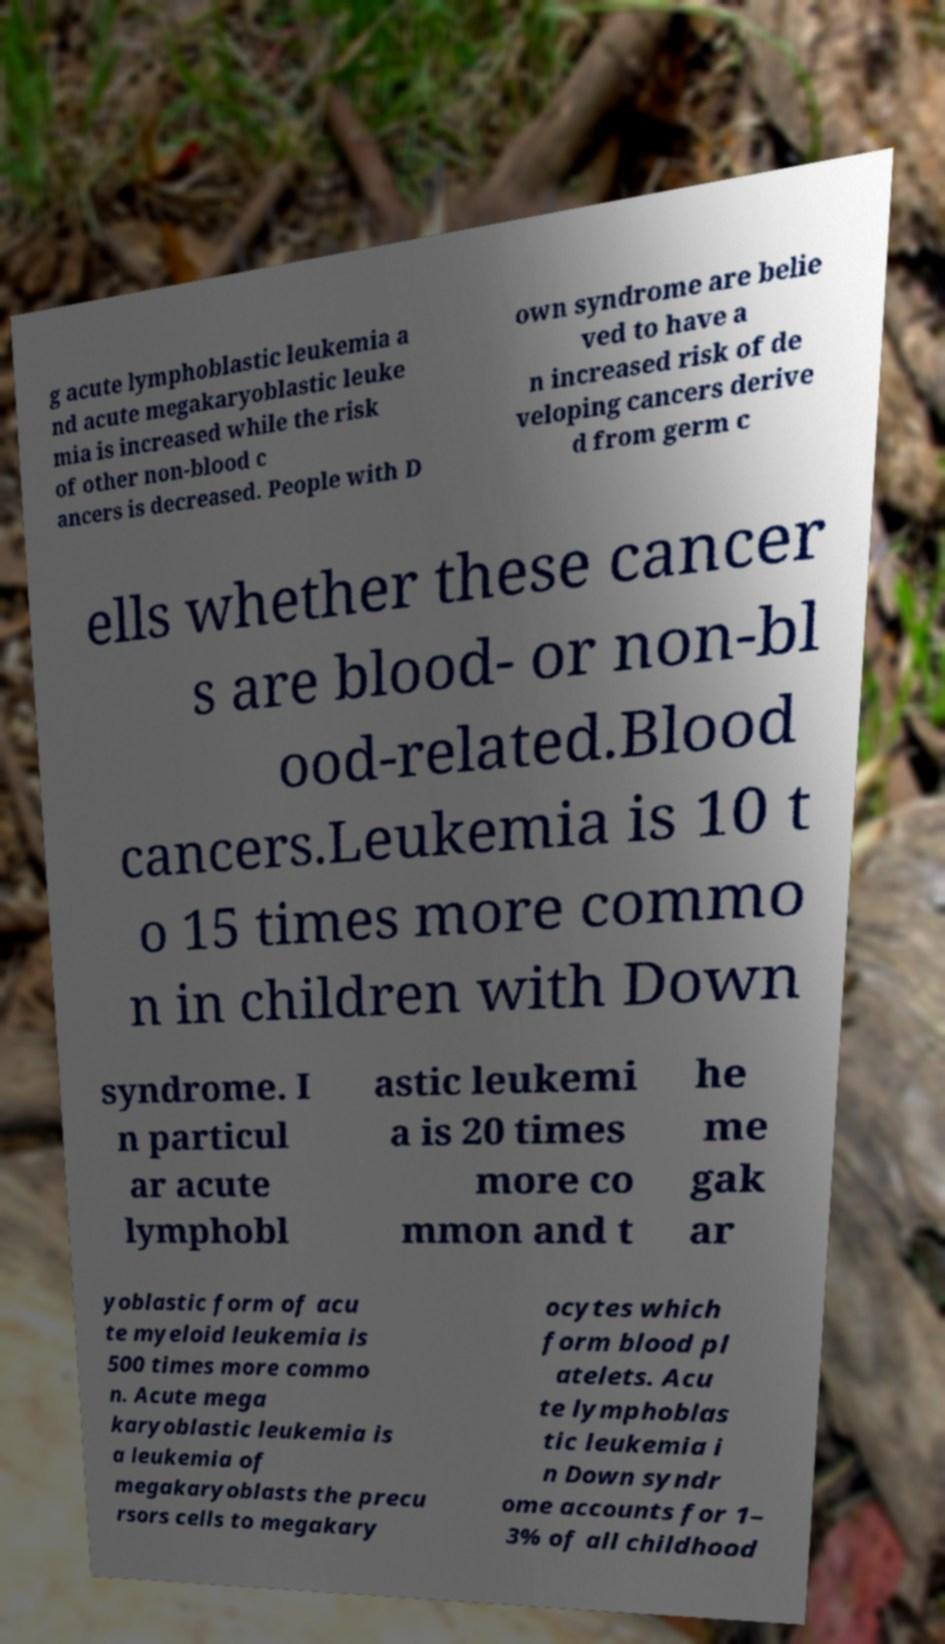Please read and relay the text visible in this image. What does it say? g acute lymphoblastic leukemia a nd acute megakaryoblastic leuke mia is increased while the risk of other non-blood c ancers is decreased. People with D own syndrome are belie ved to have a n increased risk of de veloping cancers derive d from germ c ells whether these cancer s are blood- or non-bl ood-related.Blood cancers.Leukemia is 10 t o 15 times more commo n in children with Down syndrome. I n particul ar acute lymphobl astic leukemi a is 20 times more co mmon and t he me gak ar yoblastic form of acu te myeloid leukemia is 500 times more commo n. Acute mega karyoblastic leukemia is a leukemia of megakaryoblasts the precu rsors cells to megakary ocytes which form blood pl atelets. Acu te lymphoblas tic leukemia i n Down syndr ome accounts for 1– 3% of all childhood 